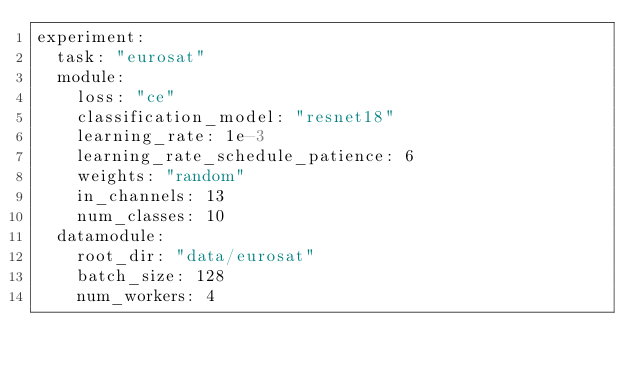Convert code to text. <code><loc_0><loc_0><loc_500><loc_500><_YAML_>experiment:
  task: "eurosat"
  module:
    loss: "ce"
    classification_model: "resnet18"
    learning_rate: 1e-3
    learning_rate_schedule_patience: 6
    weights: "random"
    in_channels: 13
    num_classes: 10
  datamodule:
    root_dir: "data/eurosat"
    batch_size: 128
    num_workers: 4
</code> 